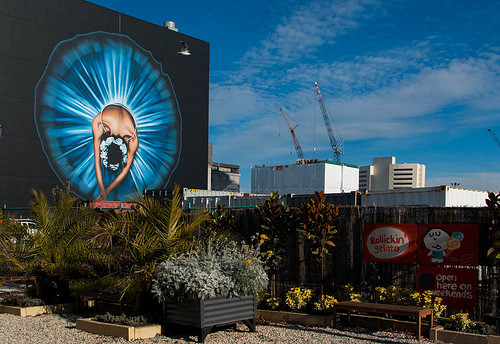<image>
Is the crane next to the building? No. The crane is not positioned next to the building. They are located in different areas of the scene. 